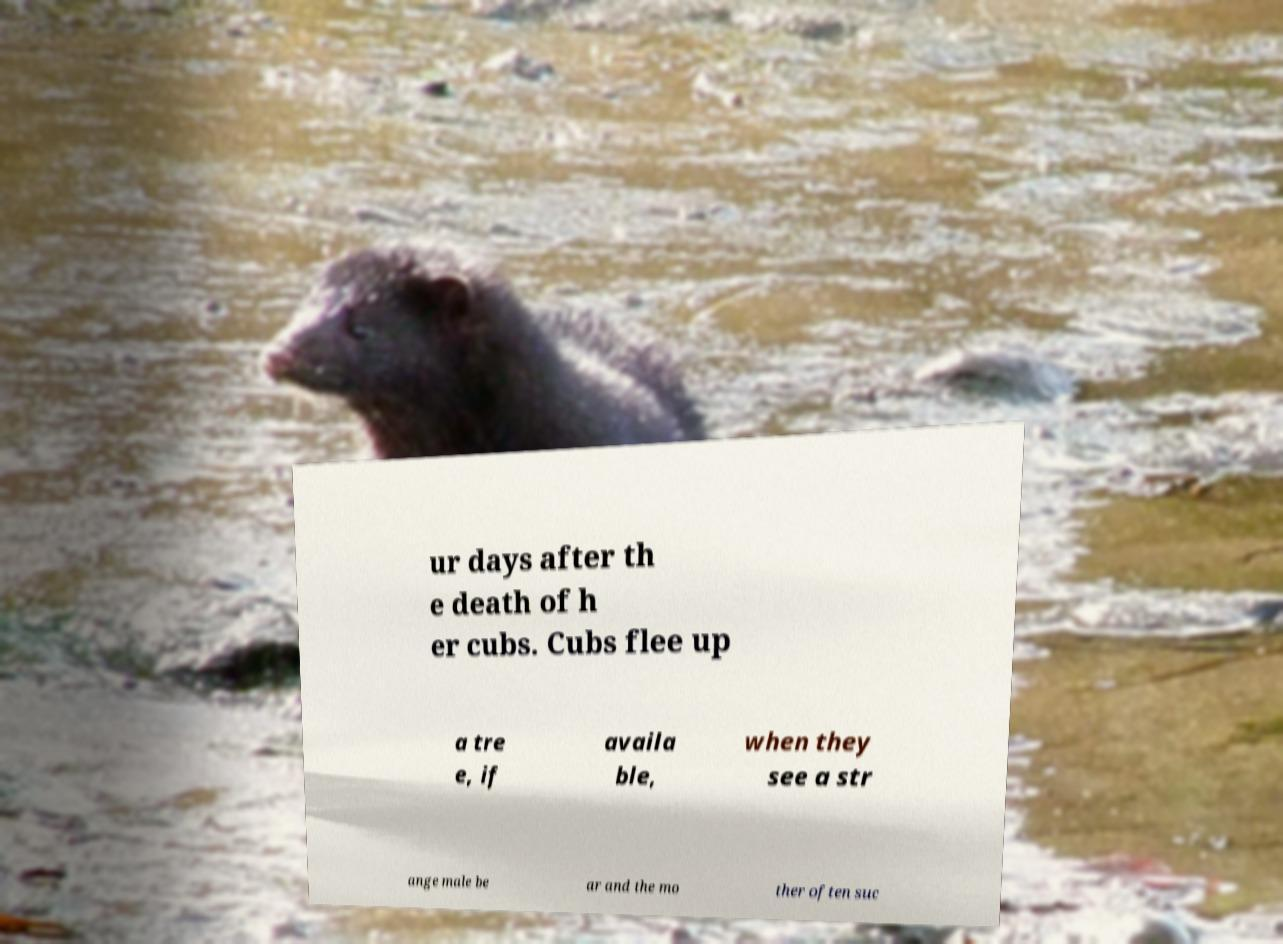Can you accurately transcribe the text from the provided image for me? ur days after th e death of h er cubs. Cubs flee up a tre e, if availa ble, when they see a str ange male be ar and the mo ther often suc 